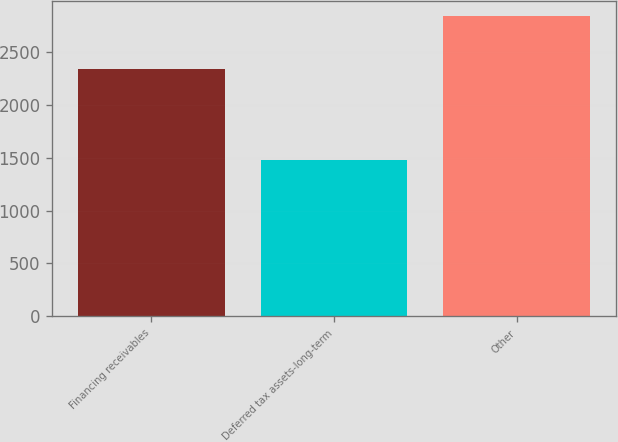Convert chart to OTSL. <chart><loc_0><loc_0><loc_500><loc_500><bar_chart><fcel>Financing receivables<fcel>Deferred tax assets-long-term<fcel>Other<nl><fcel>2340<fcel>1475<fcel>2834<nl></chart> 